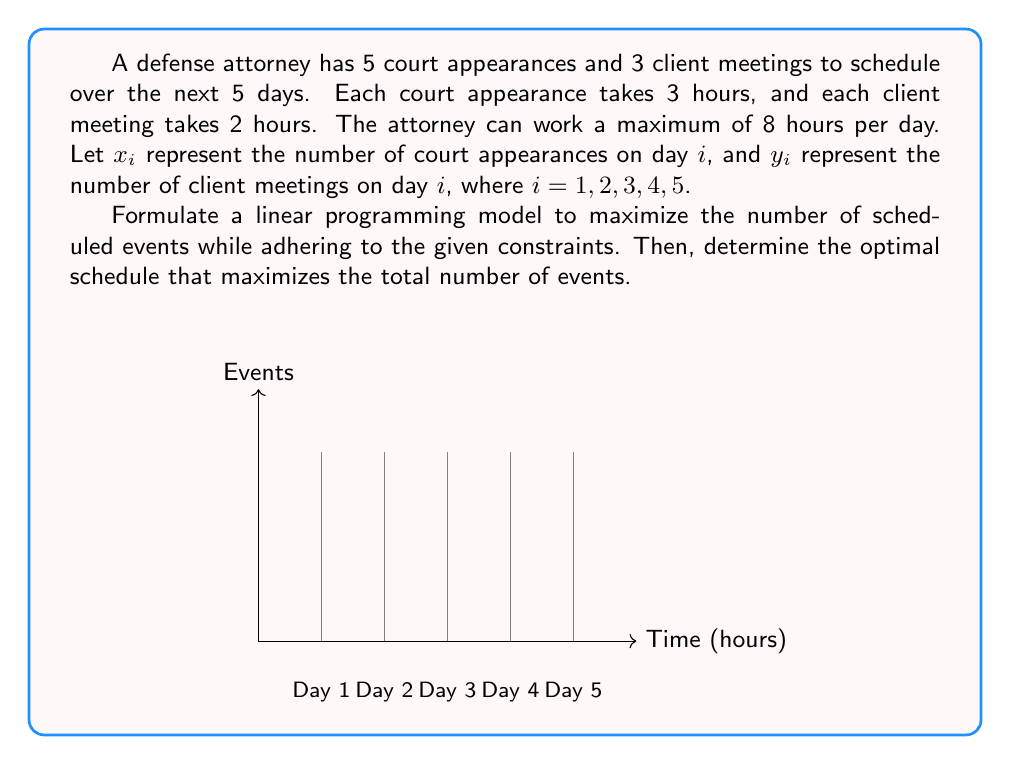Give your solution to this math problem. Let's formulate the linear programming model step by step:

1) Objective function:
   Maximize $Z = \sum_{i=1}^5 (x_i + y_i)$

2) Constraints:
   a) Time constraint for each day:
      $3x_i + 2y_i \leq 8$ for $i = 1, 2, 3, 4, 5$

   b) Total number of court appearances:
      $\sum_{i=1}^5 x_i = 5$

   c) Total number of client meetings:
      $\sum_{i=1}^5 y_i = 3$

   d) Non-negativity constraints:
      $x_i, y_i \geq 0$ and integer for $i = 1, 2, 3, 4, 5$

3) Solving the model:
   This is an Integer Linear Programming problem. We can solve it using branch and bound method or other ILP solving techniques. However, we can also use logical reasoning to find the optimal solution:

   - We need to schedule 5 court appearances (3 hours each) and 3 client meetings (2 hours each).
   - Total time required = $5 * 3 + 3 * 2 = 21$ hours
   - Available time over 5 days = $5 * 8 = 40$ hours

   Optimal schedule:
   - Day 1: 2 court appearances (6 hours)
   - Day 2: 1 court appearance (3 hours) and 2 client meetings (4 hours)
   - Day 3: 1 court appearance (3 hours) and 1 client meeting (2 hours)
   - Day 4: 1 court appearance (3 hours)
   - Day 5: No events (spare capacity)

   This schedule uses 21 hours out of the available 40 hours and includes all required events.

4) Verifying the solution:
   - All constraints are satisfied
   - Total events scheduled = 5 + 3 = 8 (maximum possible)

Therefore, this is the optimal schedule that maximizes the total number of events.
Answer: Optimal schedule: $(x_1,y_1)=(2,0)$, $(x_2,y_2)=(1,2)$, $(x_3,y_3)=(1,1)$, $(x_4,y_4)=(1,0)$, $(x_5,y_5)=(0,0)$ 